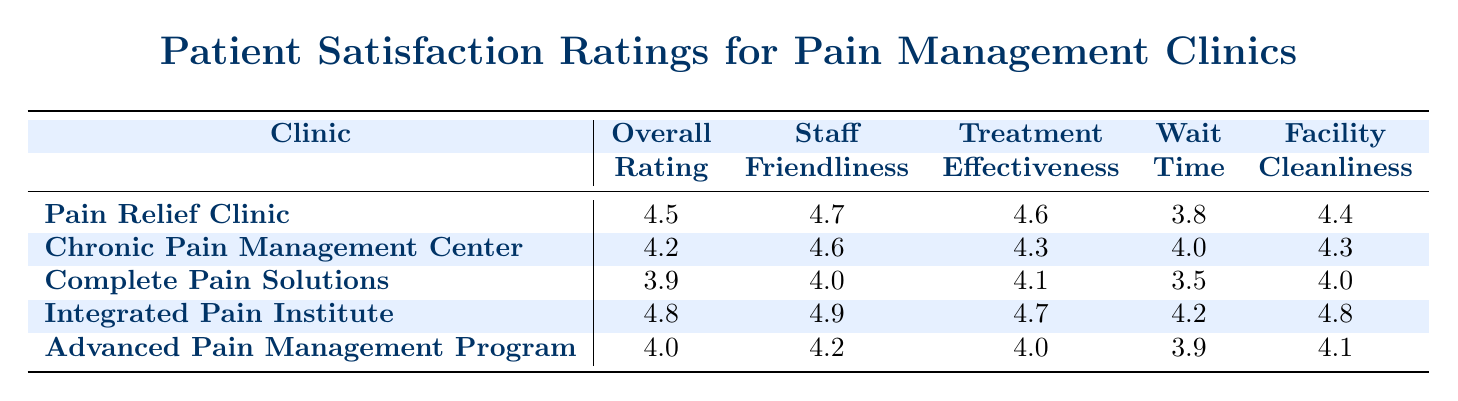What is the overall rating of the Integrated Pain Institute? The table shows the overall rating for each clinic. Looking under the "Overall Rating" column for "Integrated Pain Institute," the value provided is 4.8.
Answer: 4.8 Which clinic has the highest staff friendliness rating? The table contains the ratings for staff friendliness for each clinic. After comparing the values, "Integrated Pain Institute" has the highest rating of 4.9.
Answer: Integrated Pain Institute What is the average treatment effectiveness rating across all clinics? To find the average treatment effectiveness, sum the ratings (4.6 + 4.3 + 4.1 + 4.7 + 4.0) = 21.7. There are 5 clinics, so dividing this sum by 5 gives an average of 21.7 / 5 = 4.34.
Answer: 4.34 Is the wait time at the Pain Relief Clinic greater than 4? The wait time for the Pain Relief Clinic is listed as 3.8 in the table, which is less than 4. Therefore, the statement is false.
Answer: No Which clinic has the lowest overall rating and what is that rating? The overall ratings are compared across all clinics. "Complete Pain Solutions" has the lowest overall rating of 3.9.
Answer: Complete Pain Solutions, 3.9 What is the difference in facility cleanliness ratings between the Integrated Pain Institute and the Complete Pain Solutions? The cleanliness rating for the Integrated Pain Institute is 4.8 and for the Complete Pain Solutions is 4.0. The difference is calculated as 4.8 - 4.0 = 0.8.
Answer: 0.8 Does the Chronic Pain Management Center have a higher overall rating than the Advanced Pain Management Program? The overall rating for Chronic Pain Management Center is 4.2, while for Advanced Pain Management Program it is 4.0. Since 4.2 is greater than 4.0, the statement is true.
Answer: Yes Which clinic has the highest rating in terms of wait time, and what is that rating? Looking at the wait time ratings, "Chronic Pain Management Center" has the highest wait time rating of 4.0. This can be determined by comparing the wait times listed in the table.
Answer: Chronic Pain Management Center, 4.0 